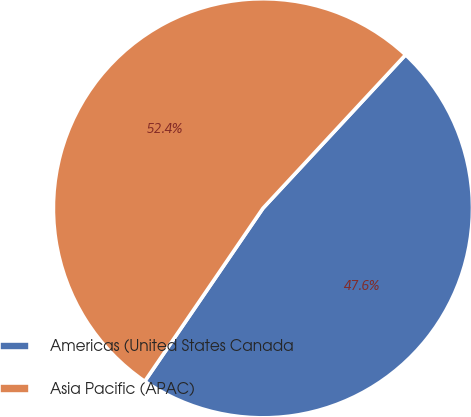Convert chart to OTSL. <chart><loc_0><loc_0><loc_500><loc_500><pie_chart><fcel>Americas (United States Canada<fcel>Asia Pacific (APAC)<nl><fcel>47.62%<fcel>52.38%<nl></chart> 